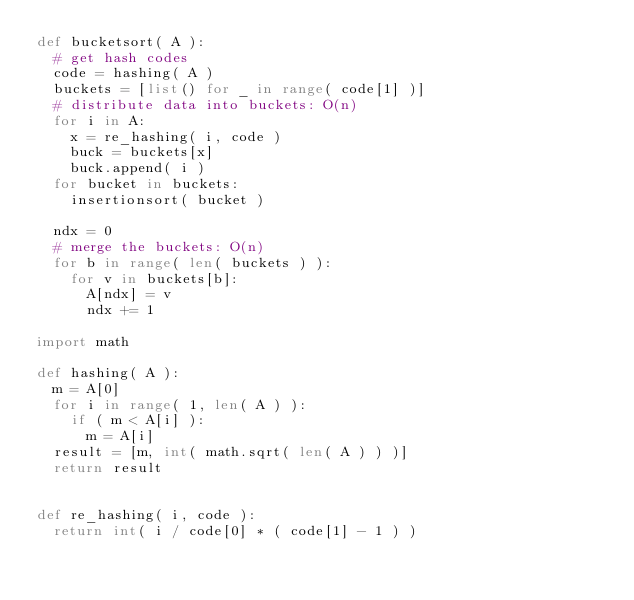Convert code to text. <code><loc_0><loc_0><loc_500><loc_500><_Python_>def bucketsort( A ):
  # get hash codes
  code = hashing( A )
  buckets = [list() for _ in range( code[1] )]
  # distribute data into buckets: O(n)
  for i in A:
    x = re_hashing( i, code )
    buck = buckets[x]
    buck.append( i )
  for bucket in buckets:
    insertionsort( bucket )
 
  ndx = 0
  # merge the buckets: O(n)
  for b in range( len( buckets ) ):
    for v in buckets[b]:
      A[ndx] = v
      ndx += 1
 
import math
 
def hashing( A ):
  m = A[0]
  for i in range( 1, len( A ) ):
    if ( m < A[i] ):
      m = A[i]
  result = [m, int( math.sqrt( len( A ) ) )]
  return result
 
 
def re_hashing( i, code ):
  return int( i / code[0] * ( code[1] - 1 ) )
</code> 